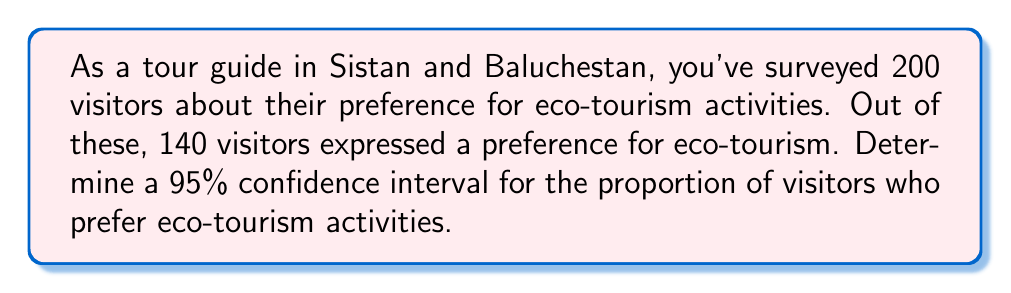Give your solution to this math problem. Let's approach this step-by-step:

1) First, we need to calculate the sample proportion:
   $\hat{p} = \frac{\text{number of successes}}{\text{sample size}} = \frac{140}{200} = 0.7$

2) For a 95% confidence interval, we use a z-score of 1.96.

3) The formula for the confidence interval is:

   $$\hat{p} \pm z\sqrt{\frac{\hat{p}(1-\hat{p})}{n}}$$

   where $\hat{p}$ is the sample proportion, $z$ is the z-score, and $n$ is the sample size.

4) Let's calculate the margin of error:

   $$\text{Margin of Error} = 1.96\sqrt{\frac{0.7(1-0.7)}{200}}$$
   $$= 1.96\sqrt{\frac{0.7(0.3)}{200}}$$
   $$= 1.96\sqrt{\frac{0.21}{200}}$$
   $$= 1.96\sqrt{0.00105}$$
   $$\approx 0.0636$$

5) Now we can calculate the confidence interval:

   Lower bound: $0.7 - 0.0636 = 0.6364$
   Upper bound: $0.7 + 0.0636 = 0.7636$

6) Therefore, we are 95% confident that the true proportion of visitors who prefer eco-tourism activities is between 0.6364 and 0.7636, or between 63.64% and 76.36%.
Answer: (0.6364, 0.7636) 